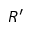Convert formula to latex. <formula><loc_0><loc_0><loc_500><loc_500>R ^ { \prime }</formula> 